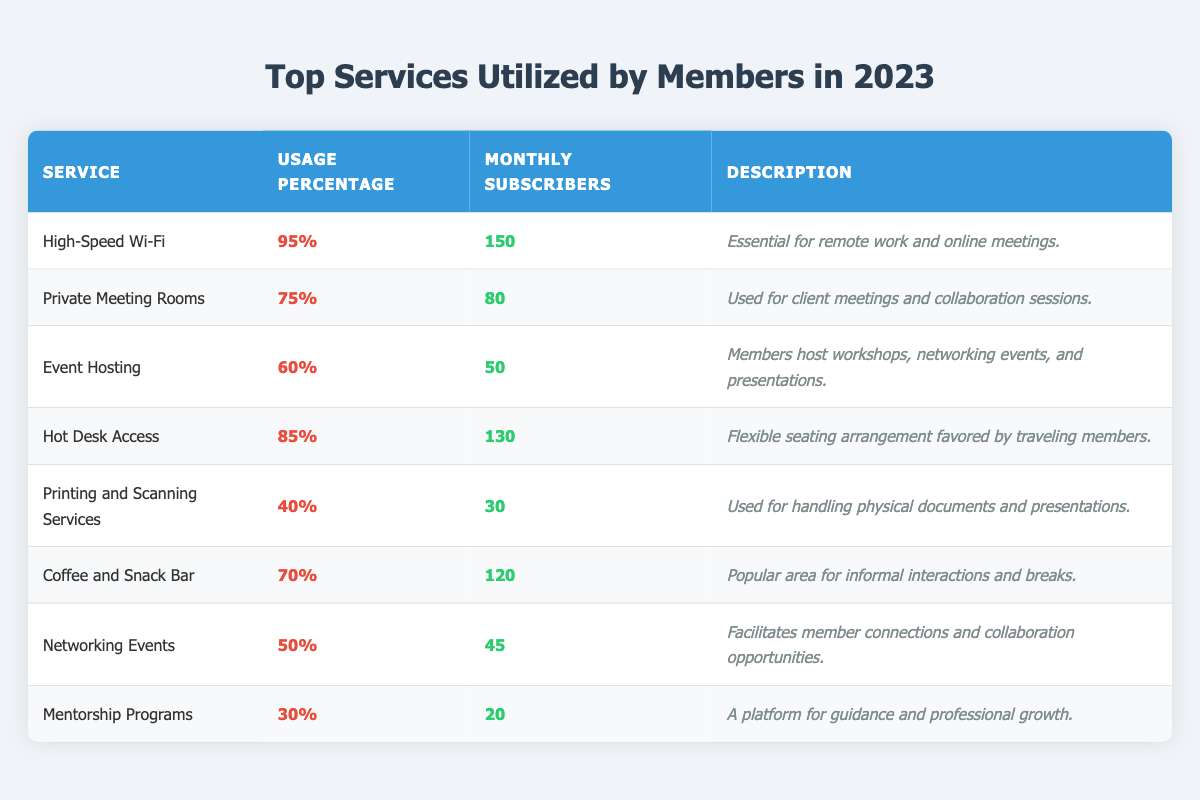What percentage of members utilize High-Speed Wi-Fi? The table states that High-Speed Wi-Fi has a usage percentage of 95%.
Answer: 95% How many monthly subscribers utilize Private Meeting Rooms? According to the table, there are 80 monthly subscribers for Private Meeting Rooms.
Answer: 80 Which service has the lowest usage percentage? The lowest usage percentage listed in the table is for Mentorship Programs at 30%.
Answer: Mentorship Programs What is the average usage percentage for services that have more than 100 monthly subscribers? The services with more than 100 monthly subscribers are High-Speed Wi-Fi (95%), Hot Desk Access (85%), and Coffee and Snack Bar (70%). Adding these gives 95 + 85 + 70 = 250. There are 3 services, so the average is 250 / 3 = 83.33%.
Answer: 83.33% Is the Coffee and Snack Bar more utilized than Networking Events? Coffee and Snack Bar has a usage percentage of 70%, while Networking Events has a usage percentage of 50%. This indicates that Coffee and Snack Bar is more utilized than Networking Events.
Answer: Yes How many total subscribers are there for all services combined? By adding the monthly subscribers from all listed services: 150 + 80 + 50 + 130 + 30 + 120 + 45 + 20 = 625.
Answer: 625 Which service is used for handling physical documents? The table describes Printing and Scanning Services as being used for handling physical documents and presentations.
Answer: Printing and Scanning Services If a new service were to attract 10% of members, how many additional monthly subscribers would that represent? Total monthly subscribers are 625. Calculating 10% of 625 gives 62.5, rounded would typically be 63 additional monthly subscribers for the new service.
Answer: 63 What services have over 70% usage and at least 100 monthly subscribers? High-Speed Wi-Fi (95% and 150 subscribers) and Hot Desk Access (85% and 130 subscribers) meet the criteria of being over 70% and having at least 100 subscribers.
Answer: High-Speed Wi-Fi and Hot Desk Access Which of the services is primarily intended for informal interactions? The Coffee and Snack Bar is noted as a popular area for informal interactions and breaks, according to the table.
Answer: Coffee and Snack Bar 